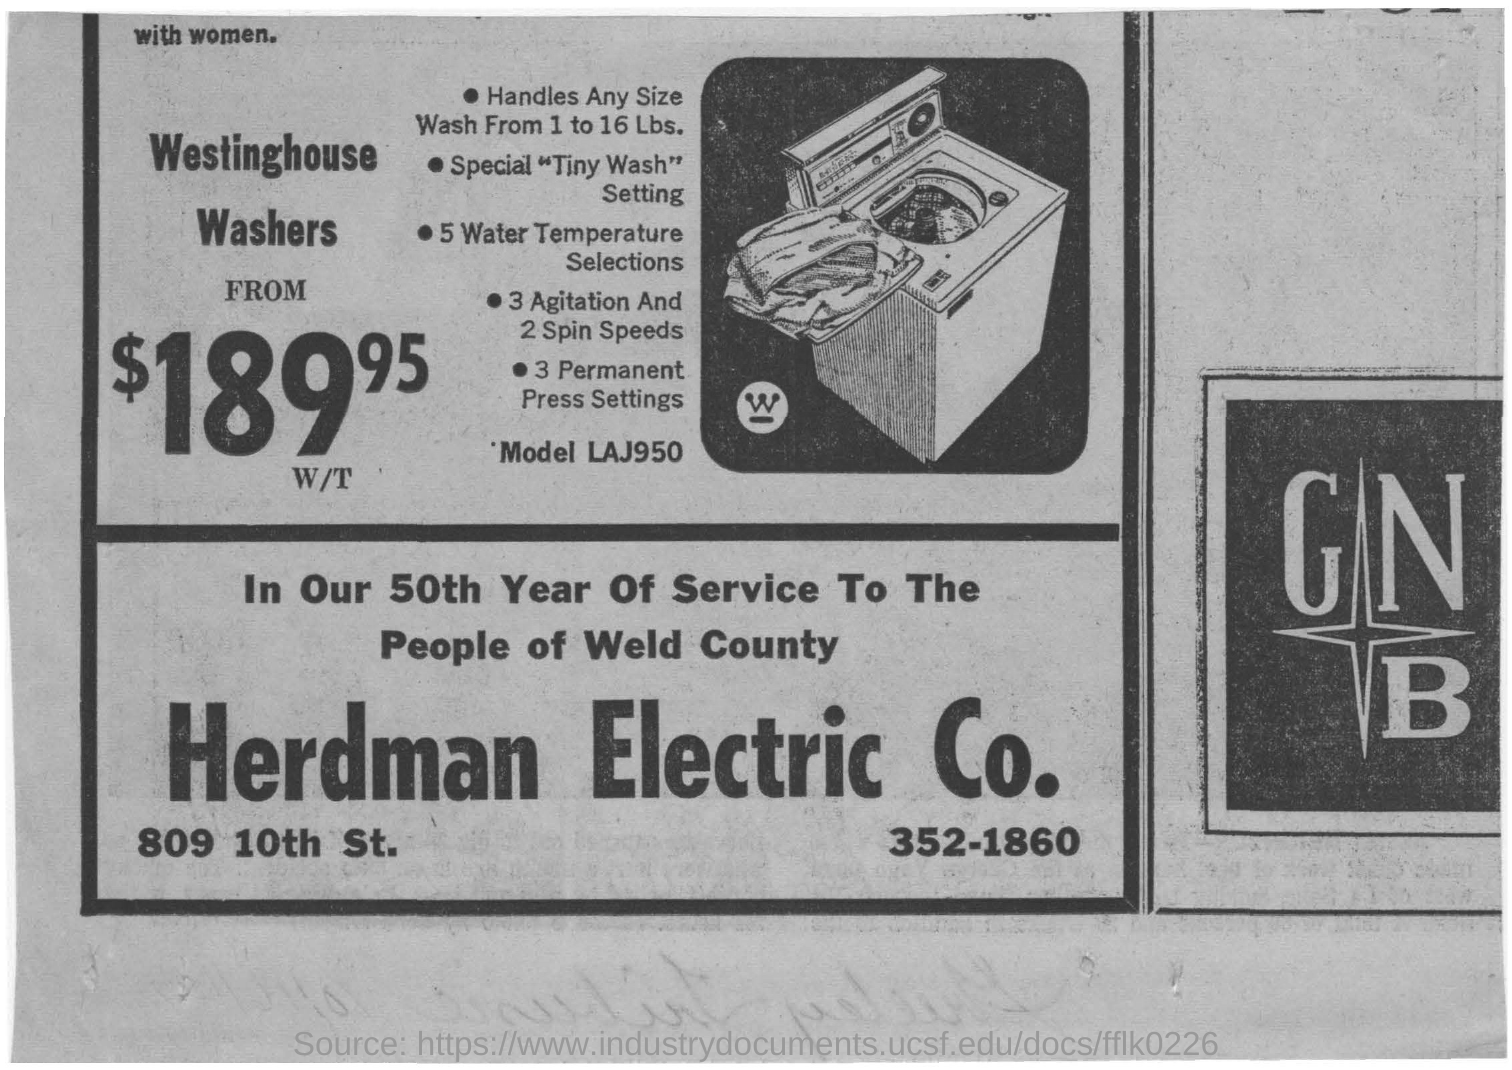What is the model mentioned there?
Your answer should be very brief. LAJ950. What is the name of the company in the image?
Ensure brevity in your answer.  Herdman Electric Co. 